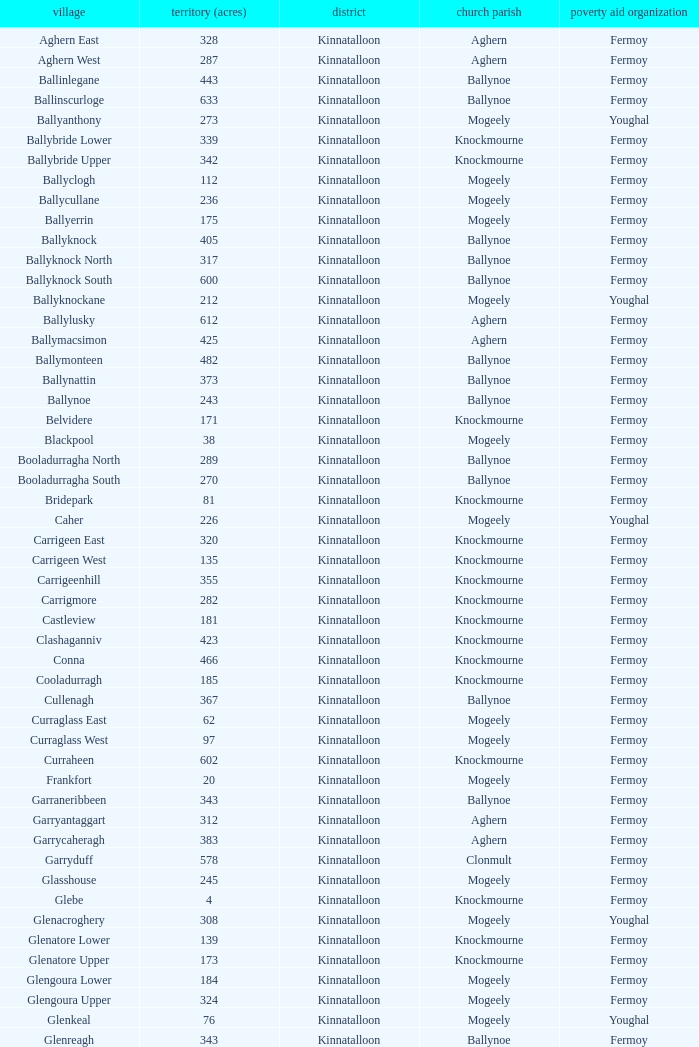Name  the townland for fermoy and ballynoe Ballinlegane, Ballinscurloge, Ballyknock, Ballyknock North, Ballyknock South, Ballymonteen, Ballynattin, Ballynoe, Booladurragha North, Booladurragha South, Cullenagh, Garraneribbeen, Glenreagh, Glentane, Killasseragh, Kilphillibeen, Knockakeo, Longueville North, Longueville South, Rathdrum, Shanaboola. 